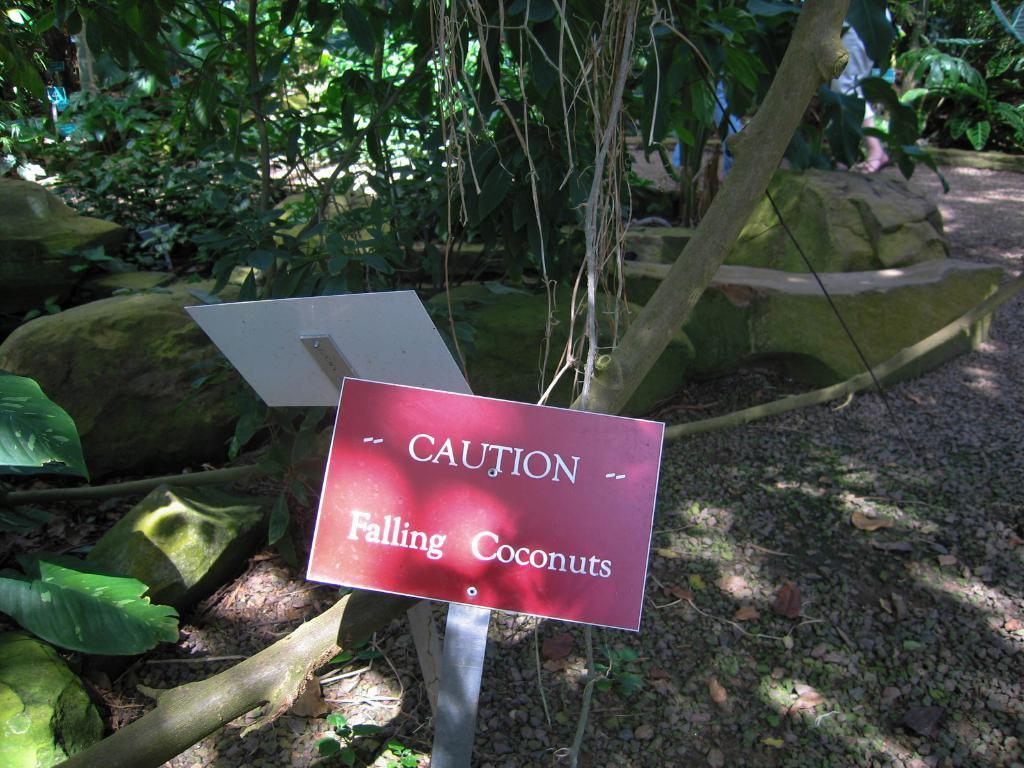What objects can be seen in the image? There are boards in the image. What can be seen in the background of the image? In the background, there are rocks, plants, trees, and people. Can you describe the natural elements visible in the image? The natural elements include rocks, plants, and trees. What type of pest can be seen crawling on the boards in the image? There are no pests visible on the boards in the image. What time of day is it during the recess in the image? There is no indication of a recess or time of day in the image. 